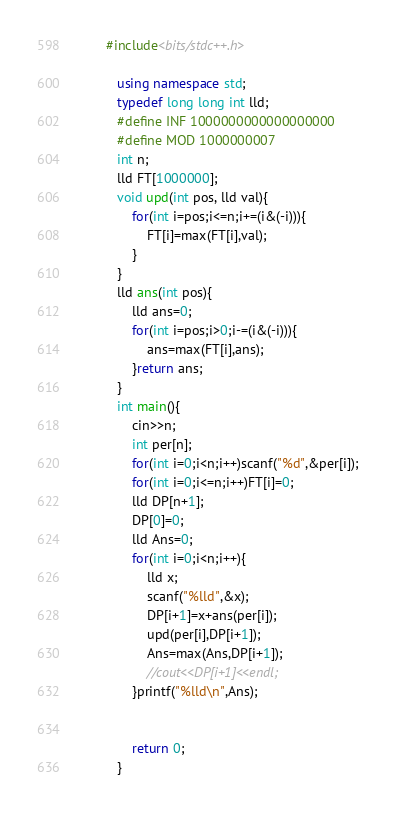Convert code to text. <code><loc_0><loc_0><loc_500><loc_500><_C++_>         #include<bits/stdc++.h>
             
            using namespace std;
            typedef long long int lld;
            #define INF 1000000000000000000
            #define MOD 1000000007
            int n;
            lld FT[1000000];
            void upd(int pos, lld val){
            	for(int i=pos;i<=n;i+=(i&(-i))){
            		FT[i]=max(FT[i],val);
            	}
            }
            lld ans(int pos){
            	lld ans=0;
            	for(int i=pos;i>0;i-=(i&(-i))){
            		ans=max(FT[i],ans);
            	}return ans;
            }
            int main(){
            	cin>>n;
            	int per[n];
            	for(int i=0;i<n;i++)scanf("%d",&per[i]);
            	for(int i=0;i<=n;i++)FT[i]=0;
            	lld DP[n+1];
            	DP[0]=0;
                lld Ans=0;
            	for(int i=0;i<n;i++){
            		lld x;
            		scanf("%lld",&x);
            		DP[i+1]=x+ans(per[i]);
            		upd(per[i],DP[i+1]);
                    Ans=max(Ans,DP[i+1]);
            		//cout<<DP[i+1]<<endl;
            	}printf("%lld\n",Ans);
            	
            	
            	return 0;
            }</code> 